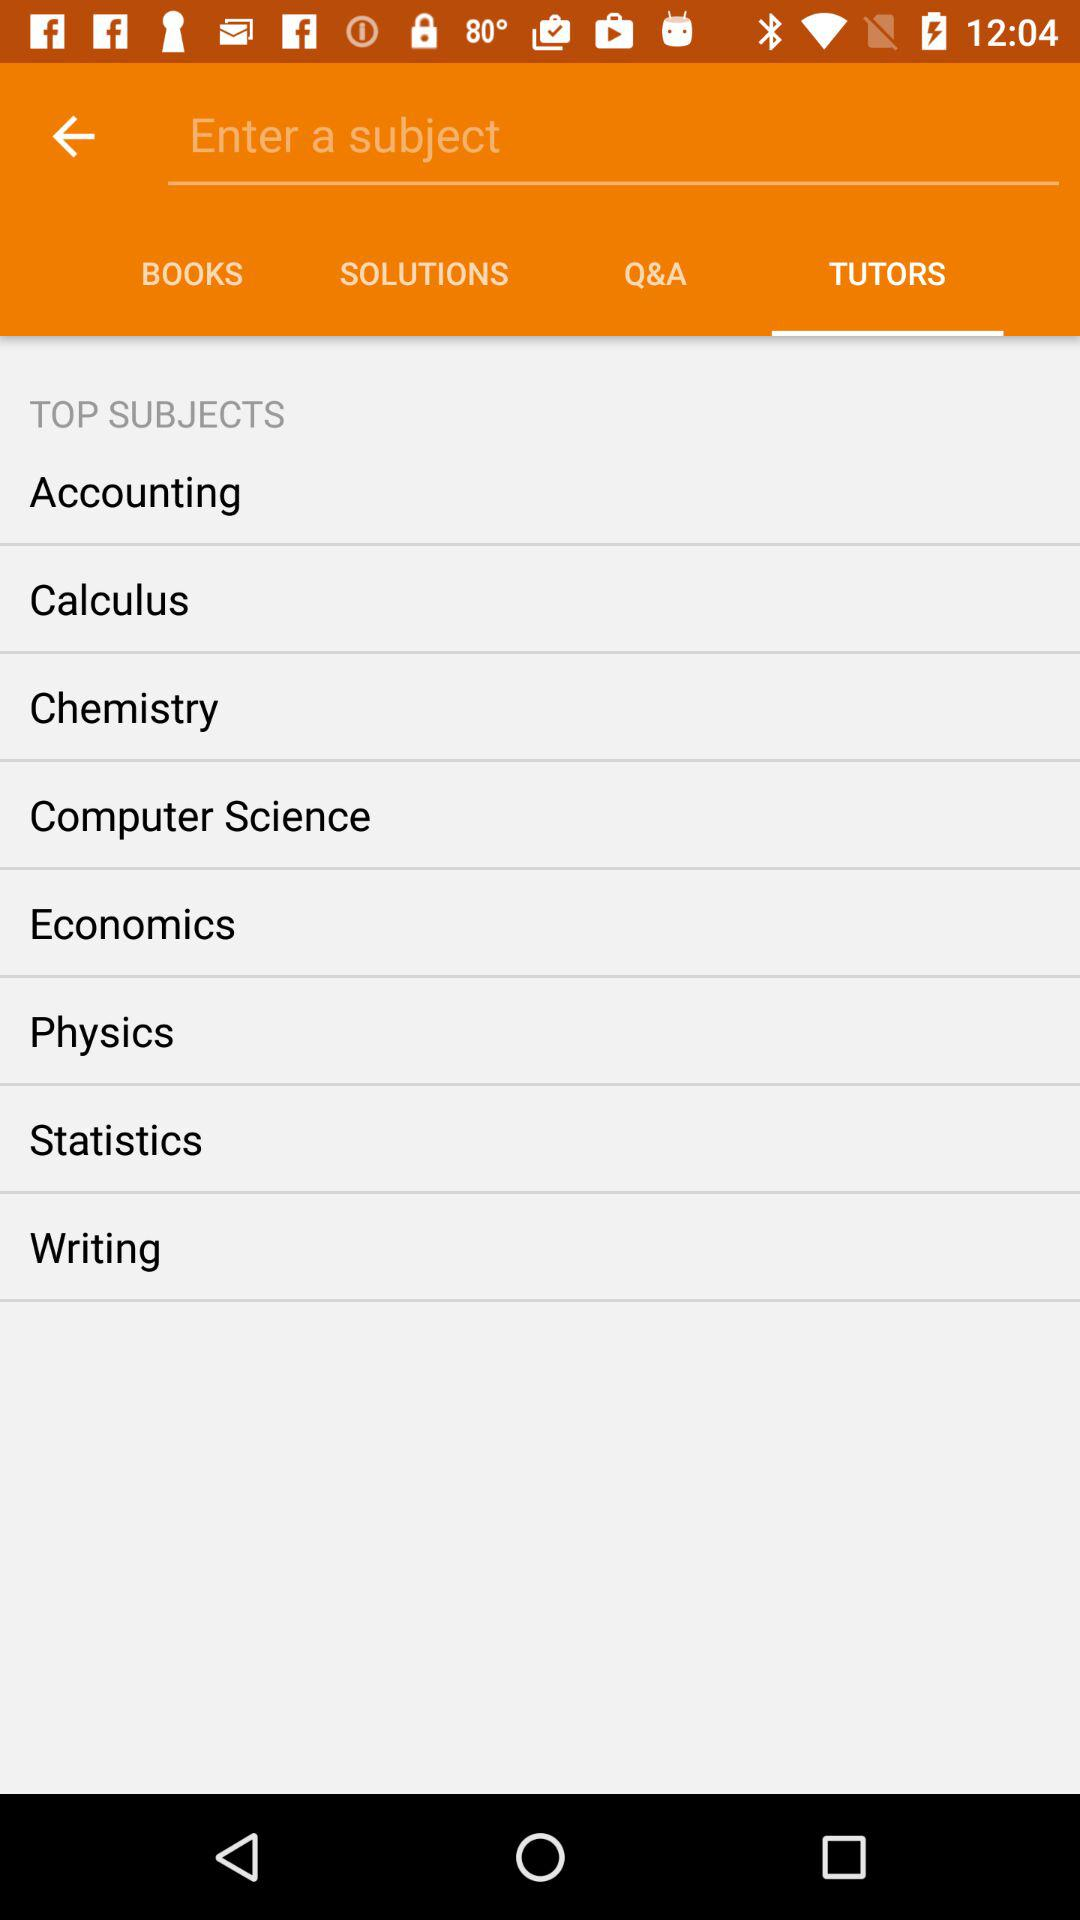Which tab is selected? The selected tab is "TUTORS". 